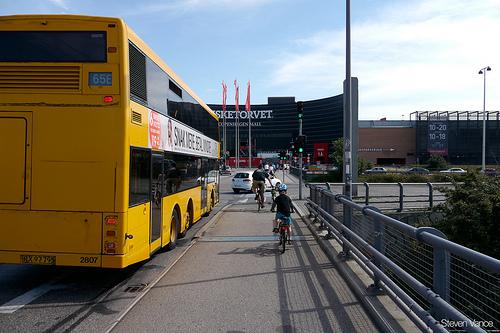Explain the role of numbers and text in this image. There is an identifier "65e" on the bus, a number "2807", and a watermark that reads "Steven Vance" in the corner. Report the main focus of the image and the immediate surroundings. The central focus is a yellow double-decker bus, surrounded by a white car, a cyclist, traffic signals, and a metal fence. Name the colors, objects, and actions of the main subjects in the picture. A yellow double-decker bus, a white car, and a bicyclist wearing a blue helmet are present in the image. Express the occurrences in this visual with an emphasis on the type of road signals and the colors they show. Two traffic signals on poles in the image, with the green light active, while a yellow bus, a white car, and a bicyclist approach. In a descriptive sentence, detail the most prominent road users in the image. A large yellow double-decker bus, a small white car, and a person riding a bicycle with a blue helmet dominate the scene. Describe the type of transportation that appears in the image. The image features a double-decker yellow bus, a white car, and a person riding a bicycle. What are the outdoor elements in this image, and describe one of them in detail. A tall light post, three red flags, a leafy tree, and metal fence are the outdoor elements, with the light post being tall and grey. Mention the central object in this picture and mention its most distinctive feature. A large yellow bus with two levels is a central object in the image. Narrate the scene involving human activity in the image. A person riding a bike, wearing a blue helmet and casting a shadow, is cycling beside a large yellow bus and a small white car. In a single sentence, encompass the main subjects and actions unfolding in the picture. The image depicts a yellow double-decker bus, a small white car, and a bicyclist wearing a blue helmet moving along a road with traffic signals. 